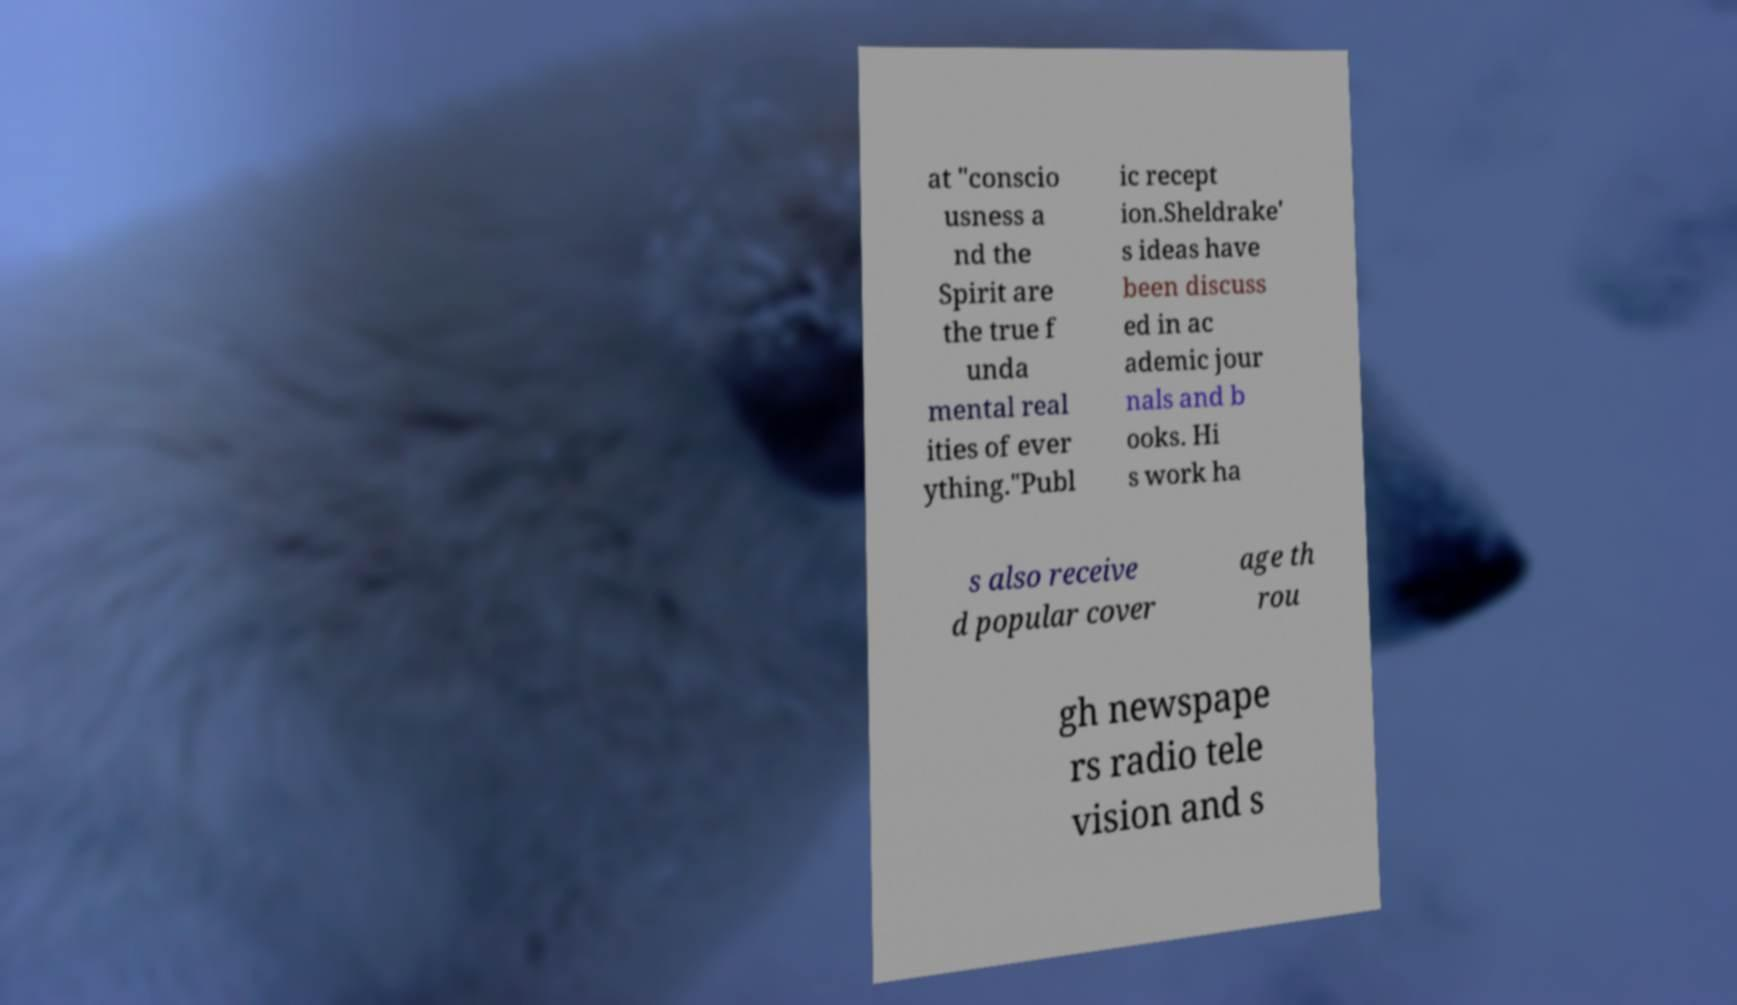Can you read and provide the text displayed in the image?This photo seems to have some interesting text. Can you extract and type it out for me? at "conscio usness a nd the Spirit are the true f unda mental real ities of ever ything."Publ ic recept ion.Sheldrake' s ideas have been discuss ed in ac ademic jour nals and b ooks. Hi s work ha s also receive d popular cover age th rou gh newspape rs radio tele vision and s 